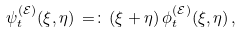Convert formula to latex. <formula><loc_0><loc_0><loc_500><loc_500>\psi _ { t } ^ { ( { \mathcal { E } } ) } ( \xi , \eta ) \, = \colon \, ( \xi + \eta ) \, \phi _ { t } ^ { ( { \mathcal { E } } ) } ( \xi , \eta ) \, ,</formula> 